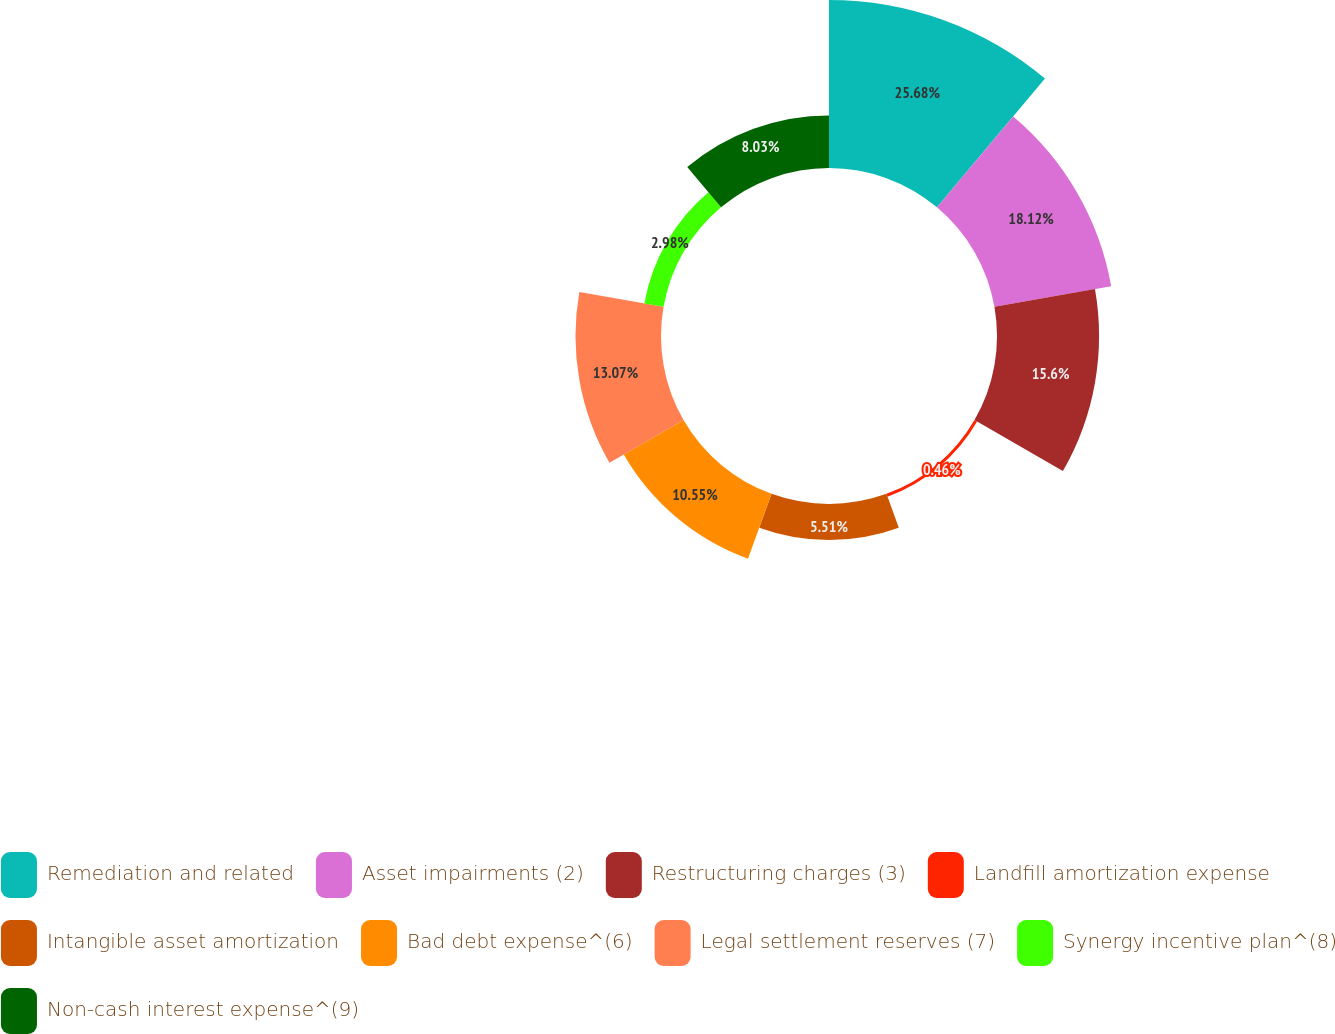<chart> <loc_0><loc_0><loc_500><loc_500><pie_chart><fcel>Remediation and related<fcel>Asset impairments (2)<fcel>Restructuring charges (3)<fcel>Landfill amortization expense<fcel>Intangible asset amortization<fcel>Bad debt expense^(6)<fcel>Legal settlement reserves (7)<fcel>Synergy incentive plan^(8)<fcel>Non-cash interest expense^(9)<nl><fcel>25.68%<fcel>18.12%<fcel>15.6%<fcel>0.46%<fcel>5.51%<fcel>10.55%<fcel>13.07%<fcel>2.98%<fcel>8.03%<nl></chart> 